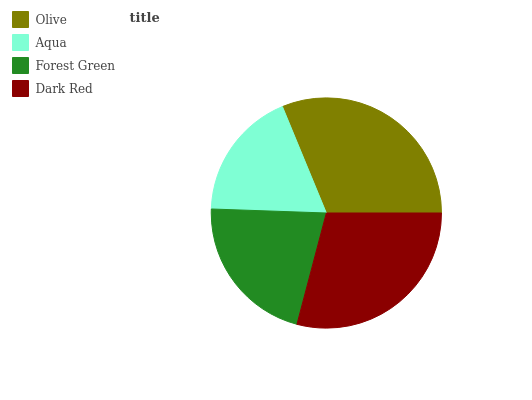Is Aqua the minimum?
Answer yes or no. Yes. Is Olive the maximum?
Answer yes or no. Yes. Is Forest Green the minimum?
Answer yes or no. No. Is Forest Green the maximum?
Answer yes or no. No. Is Forest Green greater than Aqua?
Answer yes or no. Yes. Is Aqua less than Forest Green?
Answer yes or no. Yes. Is Aqua greater than Forest Green?
Answer yes or no. No. Is Forest Green less than Aqua?
Answer yes or no. No. Is Dark Red the high median?
Answer yes or no. Yes. Is Forest Green the low median?
Answer yes or no. Yes. Is Aqua the high median?
Answer yes or no. No. Is Dark Red the low median?
Answer yes or no. No. 